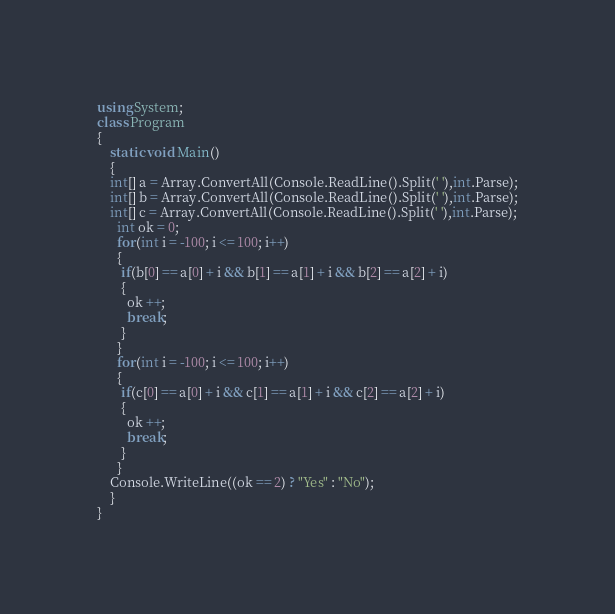Convert code to text. <code><loc_0><loc_0><loc_500><loc_500><_C#_>using System;
class Program
{
	static void Main()
	{
	int[] a = Array.ConvertAll(Console.ReadLine().Split(' '),int.Parse);
    int[] b = Array.ConvertAll(Console.ReadLine().Split(' '),int.Parse);
    int[] c = Array.ConvertAll(Console.ReadLine().Split(' '),int.Parse);
      int ok = 0;
      for(int i = -100; i <= 100; i++)
      {
       if(b[0] == a[0] + i && b[1] == a[1] + i && b[2] == a[2] + i) 
       {
         ok ++;
         break;
       }
      }
      for(int i = -100; i <= 100; i++)
      {
       if(c[0] == a[0] + i && c[1] == a[1] + i && c[2] == a[2] + i) 
       {
         ok ++;
         break;
       }
      }
	Console.WriteLine((ok == 2) ? "Yes" : "No");
	}
}</code> 